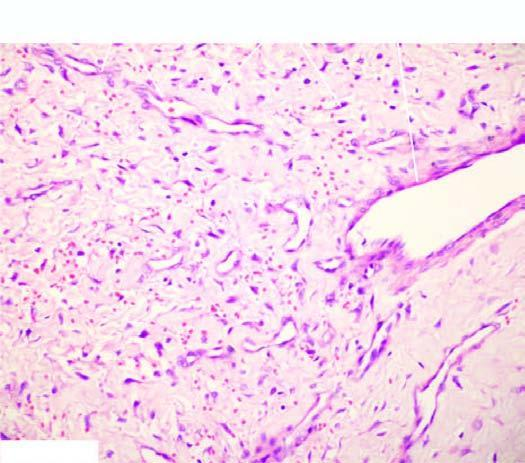does the stroma have stellate fibroblasts and mast cells?
Answer the question using a single word or phrase. Yes 